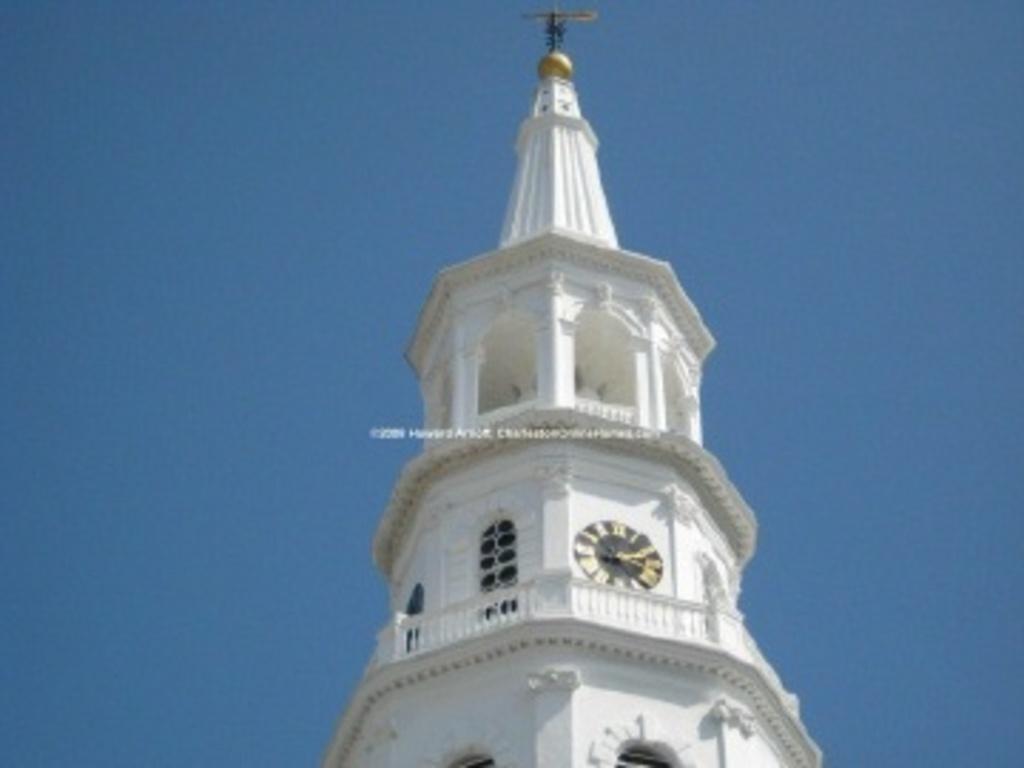Please provide a concise description of this image. In the picture we can see clock tower to which block is attached and there is clear sky. 